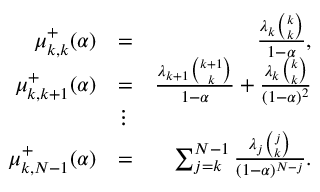<formula> <loc_0><loc_0><loc_500><loc_500>\begin{array} { r l r } { \mu _ { k , k } ^ { + } ( \alpha ) } & { = } & { \frac { \lambda _ { k } { \binom { k } { k } } } { 1 - \alpha } , } \\ { \mu _ { k , k + 1 } ^ { + } ( \alpha ) } & { = } & { \frac { \lambda _ { k + 1 } { \binom { k + 1 } { k } } } { 1 - \alpha } + \frac { \lambda _ { k } { \binom { k } { k } } } { ( 1 - \alpha ) ^ { 2 } } } \\ & { \vdots } & \\ { \mu _ { k , N - 1 } ^ { + } ( \alpha ) } & { = } & { \sum _ { j = k } ^ { N - 1 } \frac { \lambda _ { j } { \binom { j } { k } } } { ( 1 - \alpha ) ^ { N - j } } . } \end{array}</formula> 